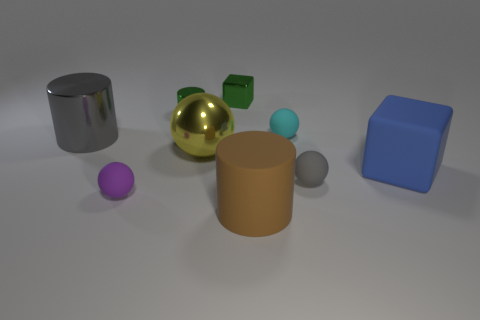Do these objects cast any shadows, and what might that indicate about the light source? Yes, each object casts a soft shadow indicating there is a diffuse light source in the scene, likely situated above and to the right of the objects. This type of lighting is commonly used to reduce harsh shadows and give a more even illumination to subjects. 